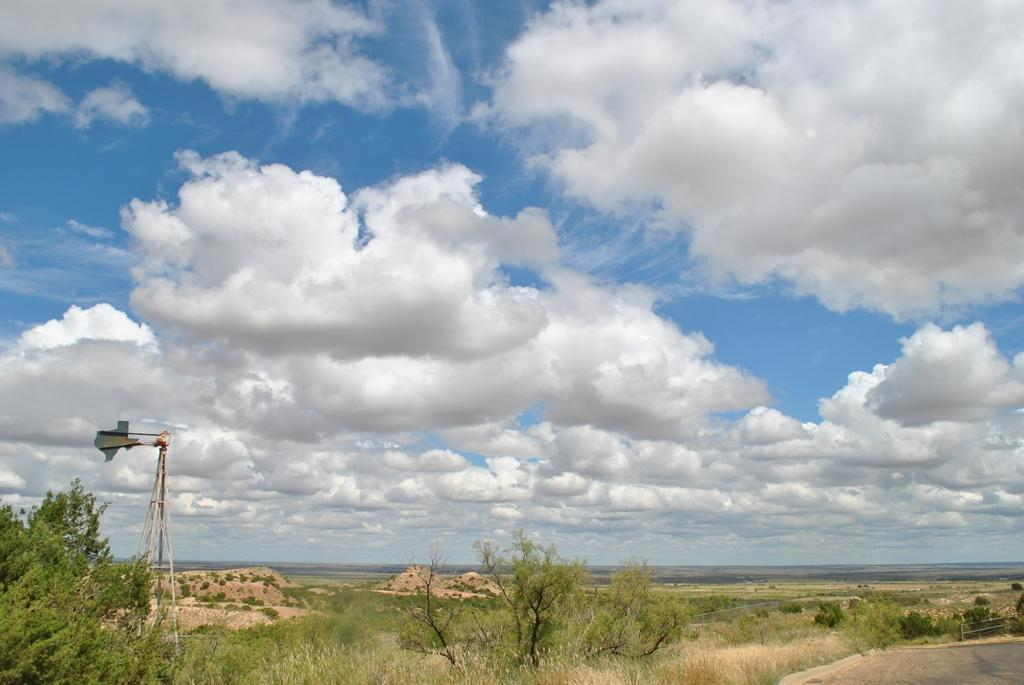What type of pathway is visible in the image? There is a road in the image. What type of vegetation can be seen in the image? There are trees and grass in the image. What structure is present in the image? There appears to be a tower in the image. What is visible in the background of the image? The sky is visible in the background of the image. What is the value of the faucet in the image? There is no faucet present in the image. What scene is depicted in the image? The image depicts a road, trees, grass, a tower, and the sky, but it does not depict a specific scene or event. 